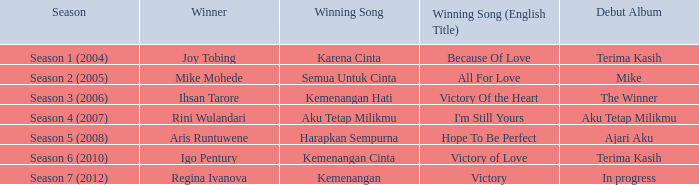Which successful song was delivered by aku tetap milikmu? I'm Still Yours. 